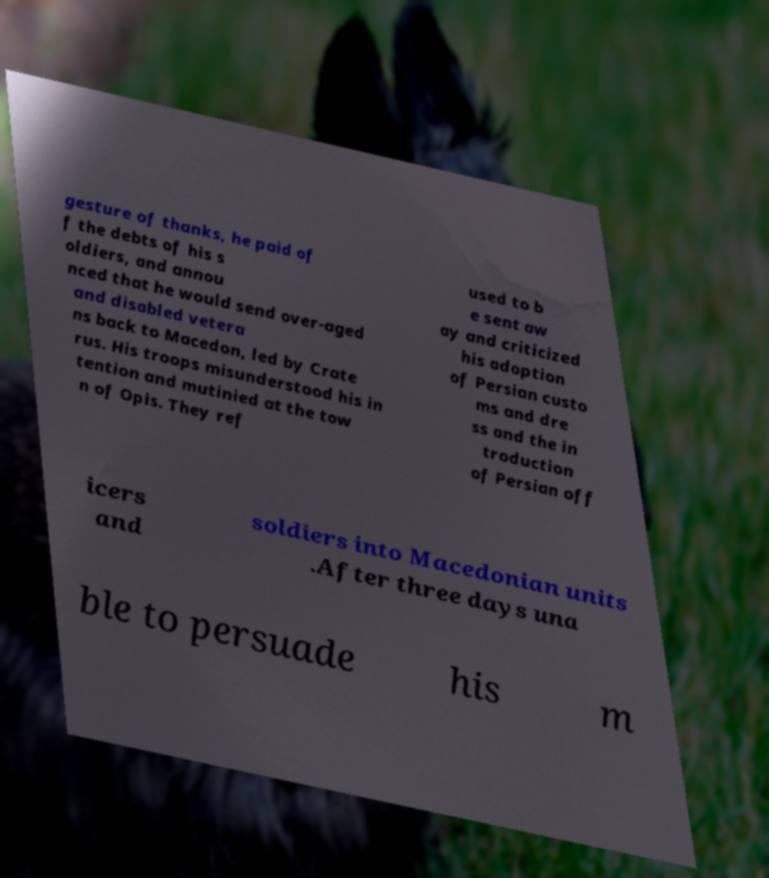Please identify and transcribe the text found in this image. gesture of thanks, he paid of f the debts of his s oldiers, and annou nced that he would send over-aged and disabled vetera ns back to Macedon, led by Crate rus. His troops misunderstood his in tention and mutinied at the tow n of Opis. They ref used to b e sent aw ay and criticized his adoption of Persian custo ms and dre ss and the in troduction of Persian off icers and soldiers into Macedonian units .After three days una ble to persuade his m 